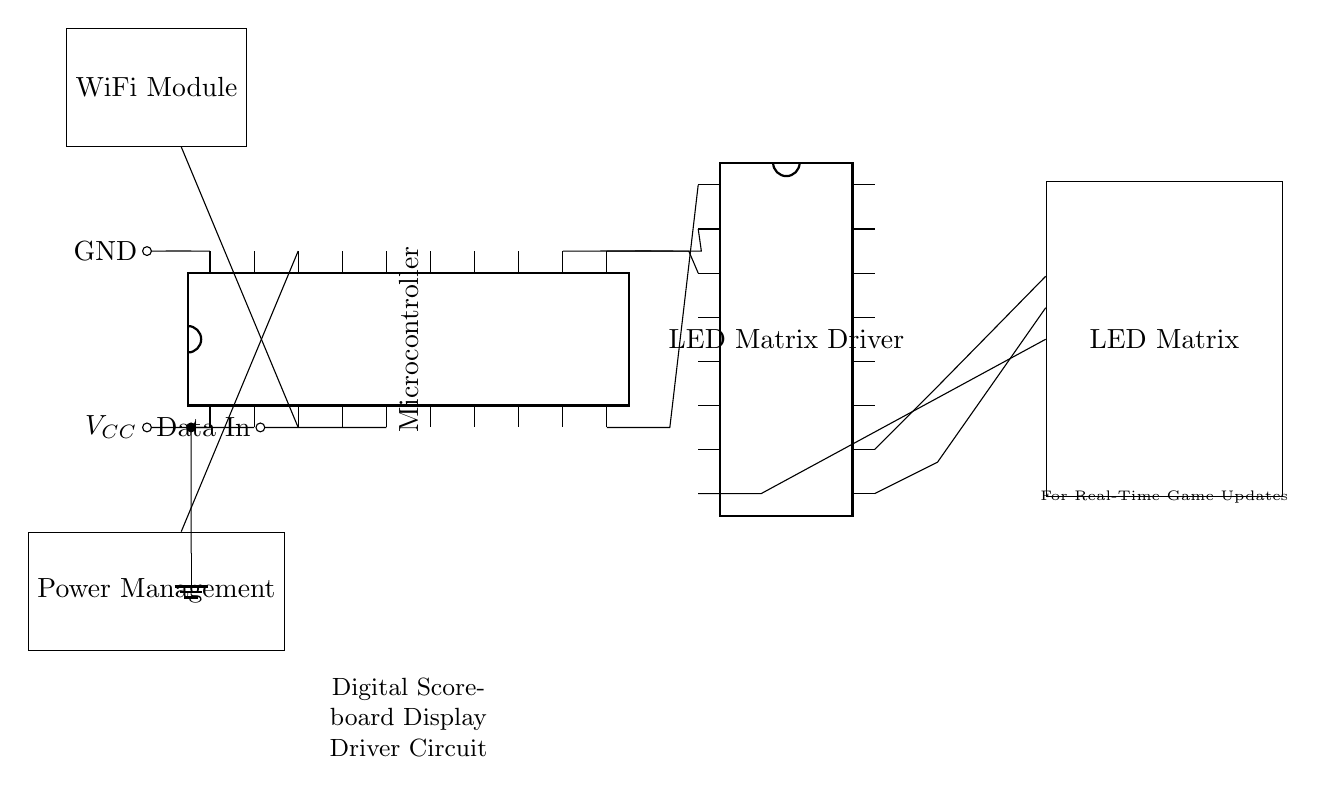What is the main function of the microcontroller? The microcontroller serves as the central processing unit that manages the data input and controls the LEDs to display the score.
Answer: Central processing Which component connects to the WiFi module? The WiFi module connects to pin three of the microcontroller, allowing wireless communication for real-time updates.
Answer: Microcontroller What is the purpose of the LED matrix driver? The LED matrix driver acts as an interface between the microcontroller and the LED matrix, controlling the light output based on the signals it receives from the microcontroller.
Answer: Interface How many pins does the LED matrix driver have? The LED matrix driver has sixteen pins as indicated in the circuit diagram.
Answer: Sixteen What voltage is provided to the circuit? The circuit uses a positive voltage supply labeled VCC; specific voltage value is not directly visible but commonly used is five volts.
Answer: VCC What role does the power management module play in the circuit? The power management module ensures that the circuit receives stable and regulated power from the supply, distributing it appropriately to the components.
Answer: Power regulation 